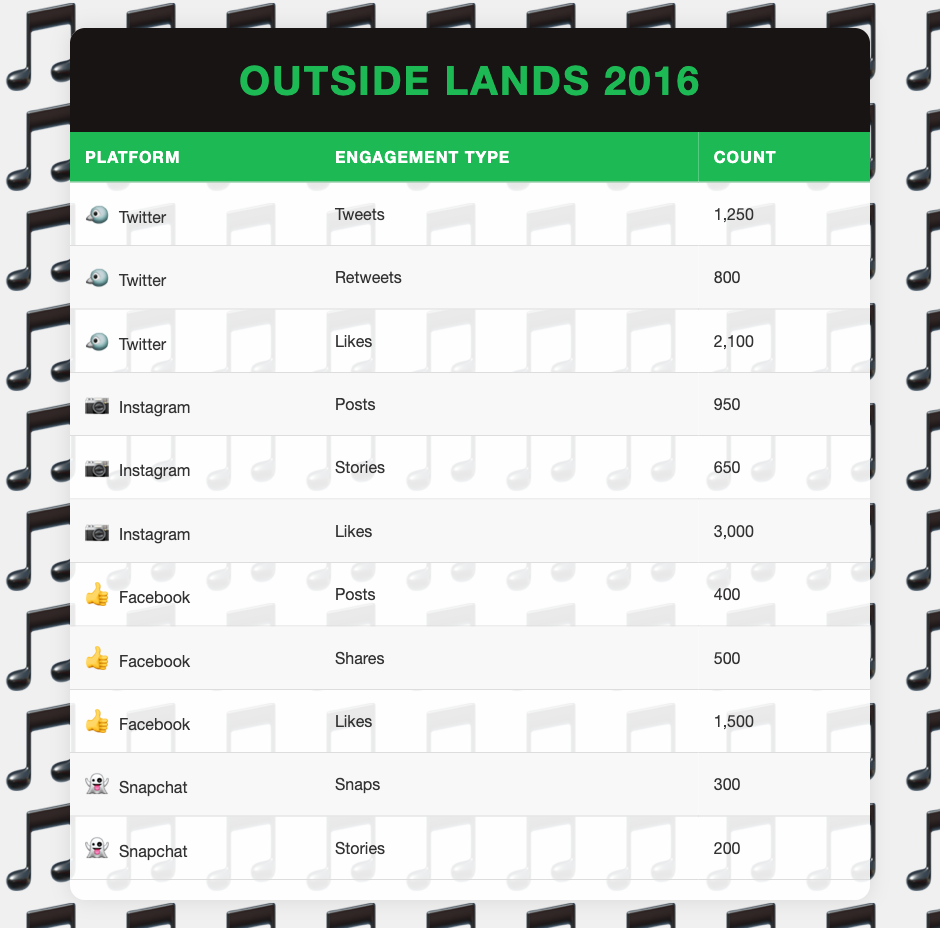What is the total number of likes on Instagram? To find the total number of likes on Instagram, we look at the row labeled "Likes" under the Instagram platform, which shows a count of 3,000. This is the only relevant row since we are specifically looking for likes on Instagram.
Answer: 3000 Which social media platform had the highest engagement count in total? We need to sum the engagement counts for each platform. For Twitter: 1250 (Tweets) + 800 (Retweets) + 2100 (Likes) = 4150; for Instagram: 950 (Posts) + 650 (Stories) + 3000 (Likes) = 4600; for Facebook: 400 (Posts) + 500 (Shares) + 1500 (Likes) = 2400; for Snapchat: 300 (Snaps) + 200 (Stories) = 500. The highest sum is 4600 for Instagram.
Answer: Instagram True or False: There were more retweets than posts on Facebook. The count for retweets on Twitter is 800, and the count for posts on Facebook is 400. Since 800 is greater than 400, the statement is true.
Answer: True What is the average count of social media engagement types for Snapchat? For Snapchat, there are two engagement types: 300 (Snaps) and 200 (Stories). To find the average, we add these values: 300 + 200 = 500, and then divide by the number of engagement types (2): 500/2 = 250.
Answer: 250 Which engagement type had the highest individual count overall? We compare the counts of all engagement types: 1250 (Tweets), 800 (Retweets), 2100 (Likes on Twitter), 950 (Posts on Instagram), 650 (Stories on Instagram), 3000 (Likes on Instagram), 400 (Posts on Facebook), 500 (Shares on Facebook), 1500 (Likes on Facebook), 300 (Snaps), and 200 (Stories on Snapchat). The highest is 3000 for Likes on Instagram.
Answer: 3000 